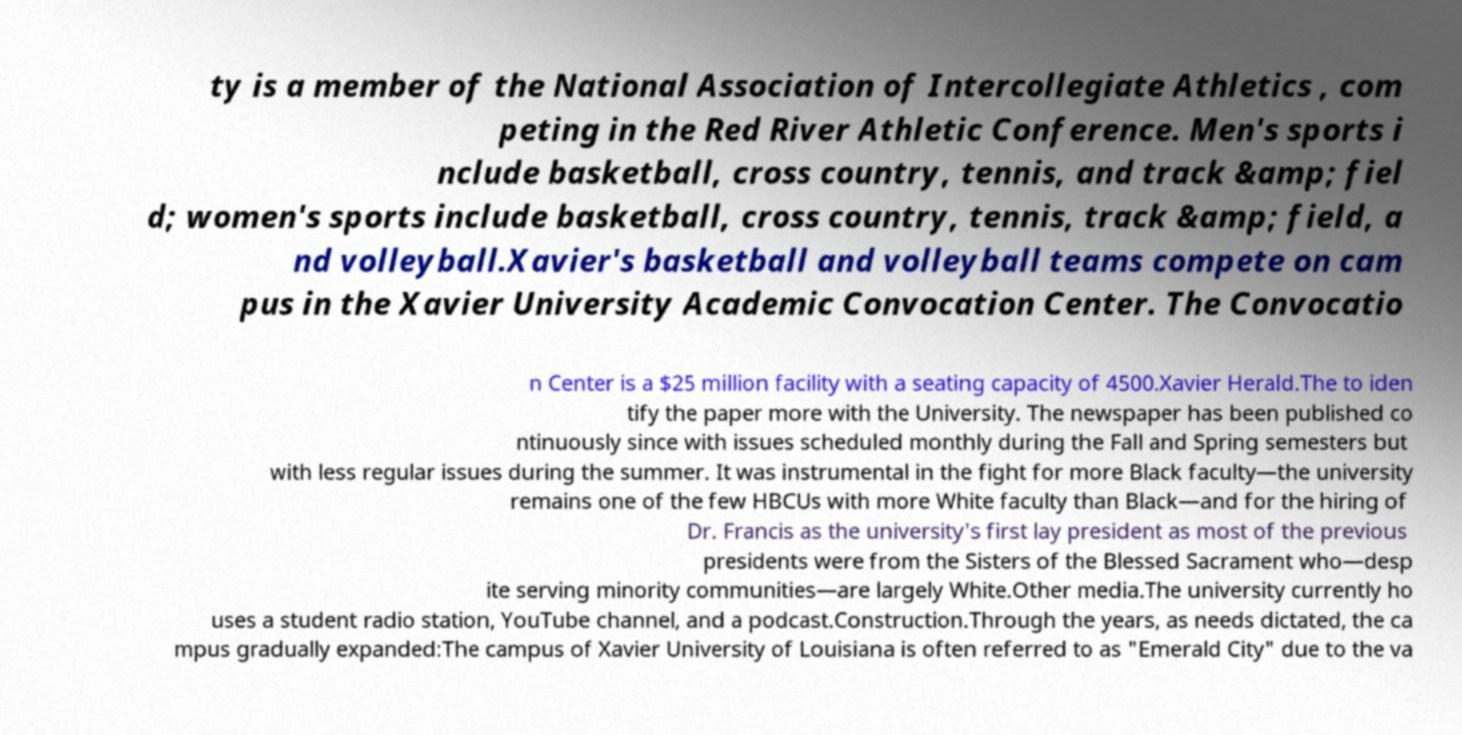There's text embedded in this image that I need extracted. Can you transcribe it verbatim? ty is a member of the National Association of Intercollegiate Athletics , com peting in the Red River Athletic Conference. Men's sports i nclude basketball, cross country, tennis, and track &amp; fiel d; women's sports include basketball, cross country, tennis, track &amp; field, a nd volleyball.Xavier's basketball and volleyball teams compete on cam pus in the Xavier University Academic Convocation Center. The Convocatio n Center is a $25 million facility with a seating capacity of 4500.Xavier Herald.The to iden tify the paper more with the University. The newspaper has been published co ntinuously since with issues scheduled monthly during the Fall and Spring semesters but with less regular issues during the summer. It was instrumental in the fight for more Black faculty—the university remains one of the few HBCUs with more White faculty than Black—and for the hiring of Dr. Francis as the university's first lay president as most of the previous presidents were from the Sisters of the Blessed Sacrament who—desp ite serving minority communities—are largely White.Other media.The university currently ho uses a student radio station, YouTube channel, and a podcast.Construction.Through the years, as needs dictated, the ca mpus gradually expanded:The campus of Xavier University of Louisiana is often referred to as "Emerald City" due to the va 